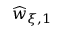Convert formula to latex. <formula><loc_0><loc_0><loc_500><loc_500>\widehat { w } _ { \xi , 1 }</formula> 